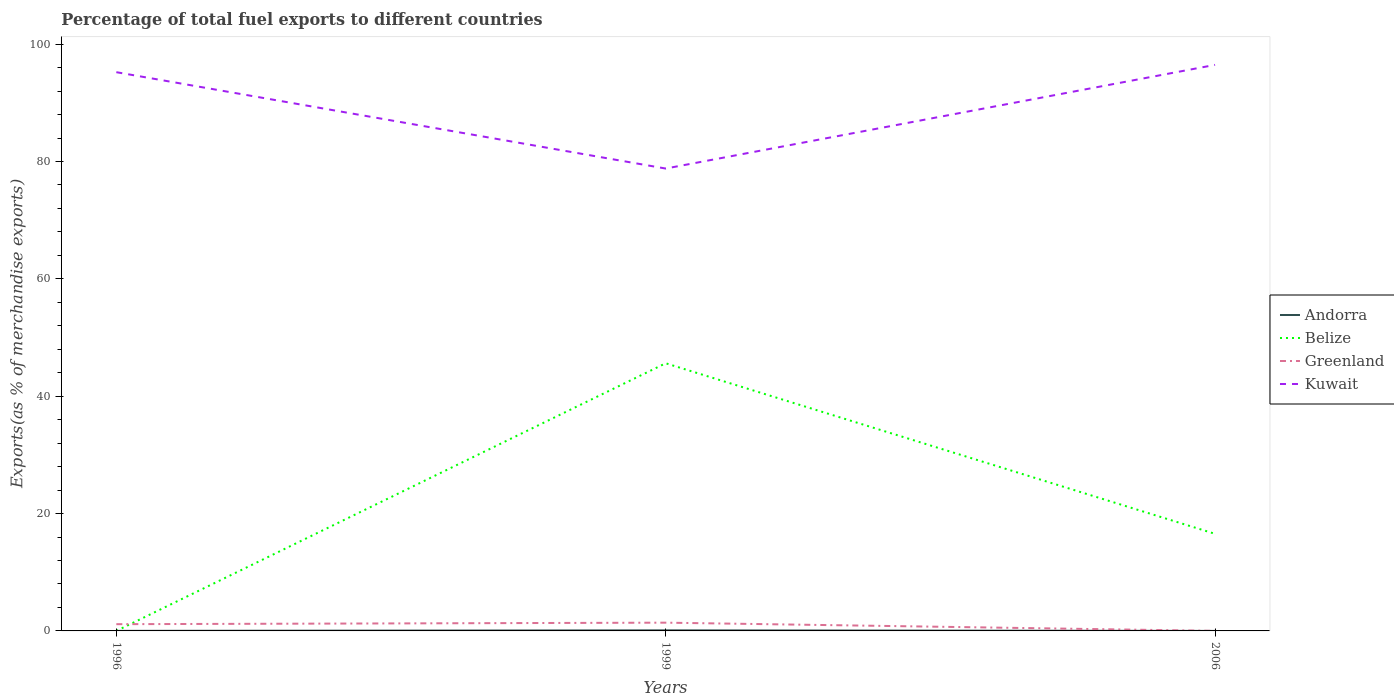Does the line corresponding to Belize intersect with the line corresponding to Kuwait?
Provide a short and direct response. No. Is the number of lines equal to the number of legend labels?
Your answer should be compact. Yes. Across all years, what is the maximum percentage of exports to different countries in Greenland?
Offer a terse response. 0.01. What is the total percentage of exports to different countries in Greenland in the graph?
Keep it short and to the point. 1.14. What is the difference between the highest and the second highest percentage of exports to different countries in Kuwait?
Your answer should be compact. 17.67. Are the values on the major ticks of Y-axis written in scientific E-notation?
Make the answer very short. No. Does the graph contain any zero values?
Make the answer very short. No. Does the graph contain grids?
Offer a very short reply. No. Where does the legend appear in the graph?
Give a very brief answer. Center right. What is the title of the graph?
Provide a succinct answer. Percentage of total fuel exports to different countries. What is the label or title of the Y-axis?
Offer a very short reply. Exports(as % of merchandise exports). What is the Exports(as % of merchandise exports) of Andorra in 1996?
Offer a very short reply. 0.01. What is the Exports(as % of merchandise exports) of Belize in 1996?
Ensure brevity in your answer.  0. What is the Exports(as % of merchandise exports) in Greenland in 1996?
Your answer should be compact. 1.15. What is the Exports(as % of merchandise exports) of Kuwait in 1996?
Give a very brief answer. 95.22. What is the Exports(as % of merchandise exports) in Andorra in 1999?
Your response must be concise. 0.1. What is the Exports(as % of merchandise exports) in Belize in 1999?
Provide a short and direct response. 45.62. What is the Exports(as % of merchandise exports) of Greenland in 1999?
Your response must be concise. 1.41. What is the Exports(as % of merchandise exports) in Kuwait in 1999?
Keep it short and to the point. 78.8. What is the Exports(as % of merchandise exports) in Andorra in 2006?
Give a very brief answer. 0. What is the Exports(as % of merchandise exports) in Belize in 2006?
Provide a succinct answer. 16.55. What is the Exports(as % of merchandise exports) of Greenland in 2006?
Provide a short and direct response. 0.01. What is the Exports(as % of merchandise exports) of Kuwait in 2006?
Ensure brevity in your answer.  96.47. Across all years, what is the maximum Exports(as % of merchandise exports) in Andorra?
Ensure brevity in your answer.  0.1. Across all years, what is the maximum Exports(as % of merchandise exports) of Belize?
Make the answer very short. 45.62. Across all years, what is the maximum Exports(as % of merchandise exports) of Greenland?
Provide a succinct answer. 1.41. Across all years, what is the maximum Exports(as % of merchandise exports) in Kuwait?
Offer a terse response. 96.47. Across all years, what is the minimum Exports(as % of merchandise exports) in Andorra?
Provide a succinct answer. 0. Across all years, what is the minimum Exports(as % of merchandise exports) in Belize?
Ensure brevity in your answer.  0. Across all years, what is the minimum Exports(as % of merchandise exports) of Greenland?
Provide a succinct answer. 0.01. Across all years, what is the minimum Exports(as % of merchandise exports) in Kuwait?
Make the answer very short. 78.8. What is the total Exports(as % of merchandise exports) of Andorra in the graph?
Your answer should be very brief. 0.11. What is the total Exports(as % of merchandise exports) of Belize in the graph?
Your answer should be very brief. 62.16. What is the total Exports(as % of merchandise exports) in Greenland in the graph?
Offer a terse response. 2.56. What is the total Exports(as % of merchandise exports) of Kuwait in the graph?
Ensure brevity in your answer.  270.5. What is the difference between the Exports(as % of merchandise exports) in Andorra in 1996 and that in 1999?
Give a very brief answer. -0.09. What is the difference between the Exports(as % of merchandise exports) in Belize in 1996 and that in 1999?
Offer a terse response. -45.62. What is the difference between the Exports(as % of merchandise exports) in Greenland in 1996 and that in 1999?
Ensure brevity in your answer.  -0.26. What is the difference between the Exports(as % of merchandise exports) in Kuwait in 1996 and that in 1999?
Offer a very short reply. 16.42. What is the difference between the Exports(as % of merchandise exports) of Andorra in 1996 and that in 2006?
Your answer should be very brief. 0.01. What is the difference between the Exports(as % of merchandise exports) in Belize in 1996 and that in 2006?
Make the answer very short. -16.55. What is the difference between the Exports(as % of merchandise exports) in Greenland in 1996 and that in 2006?
Your answer should be compact. 1.14. What is the difference between the Exports(as % of merchandise exports) of Kuwait in 1996 and that in 2006?
Make the answer very short. -1.25. What is the difference between the Exports(as % of merchandise exports) of Andorra in 1999 and that in 2006?
Provide a succinct answer. 0.1. What is the difference between the Exports(as % of merchandise exports) in Belize in 1999 and that in 2006?
Provide a short and direct response. 29.07. What is the difference between the Exports(as % of merchandise exports) in Greenland in 1999 and that in 2006?
Your response must be concise. 1.4. What is the difference between the Exports(as % of merchandise exports) of Kuwait in 1999 and that in 2006?
Offer a terse response. -17.67. What is the difference between the Exports(as % of merchandise exports) of Andorra in 1996 and the Exports(as % of merchandise exports) of Belize in 1999?
Your answer should be compact. -45.61. What is the difference between the Exports(as % of merchandise exports) in Andorra in 1996 and the Exports(as % of merchandise exports) in Greenland in 1999?
Provide a succinct answer. -1.4. What is the difference between the Exports(as % of merchandise exports) of Andorra in 1996 and the Exports(as % of merchandise exports) of Kuwait in 1999?
Provide a short and direct response. -78.79. What is the difference between the Exports(as % of merchandise exports) of Belize in 1996 and the Exports(as % of merchandise exports) of Greenland in 1999?
Provide a short and direct response. -1.41. What is the difference between the Exports(as % of merchandise exports) of Belize in 1996 and the Exports(as % of merchandise exports) of Kuwait in 1999?
Make the answer very short. -78.8. What is the difference between the Exports(as % of merchandise exports) in Greenland in 1996 and the Exports(as % of merchandise exports) in Kuwait in 1999?
Provide a succinct answer. -77.65. What is the difference between the Exports(as % of merchandise exports) of Andorra in 1996 and the Exports(as % of merchandise exports) of Belize in 2006?
Your answer should be compact. -16.54. What is the difference between the Exports(as % of merchandise exports) of Andorra in 1996 and the Exports(as % of merchandise exports) of Greenland in 2006?
Offer a terse response. 0. What is the difference between the Exports(as % of merchandise exports) of Andorra in 1996 and the Exports(as % of merchandise exports) of Kuwait in 2006?
Offer a very short reply. -96.46. What is the difference between the Exports(as % of merchandise exports) of Belize in 1996 and the Exports(as % of merchandise exports) of Greenland in 2006?
Ensure brevity in your answer.  -0.01. What is the difference between the Exports(as % of merchandise exports) of Belize in 1996 and the Exports(as % of merchandise exports) of Kuwait in 2006?
Give a very brief answer. -96.47. What is the difference between the Exports(as % of merchandise exports) in Greenland in 1996 and the Exports(as % of merchandise exports) in Kuwait in 2006?
Offer a very short reply. -95.32. What is the difference between the Exports(as % of merchandise exports) of Andorra in 1999 and the Exports(as % of merchandise exports) of Belize in 2006?
Your answer should be very brief. -16.45. What is the difference between the Exports(as % of merchandise exports) of Andorra in 1999 and the Exports(as % of merchandise exports) of Greenland in 2006?
Your response must be concise. 0.09. What is the difference between the Exports(as % of merchandise exports) of Andorra in 1999 and the Exports(as % of merchandise exports) of Kuwait in 2006?
Make the answer very short. -96.37. What is the difference between the Exports(as % of merchandise exports) of Belize in 1999 and the Exports(as % of merchandise exports) of Greenland in 2006?
Your response must be concise. 45.61. What is the difference between the Exports(as % of merchandise exports) of Belize in 1999 and the Exports(as % of merchandise exports) of Kuwait in 2006?
Provide a succinct answer. -50.85. What is the difference between the Exports(as % of merchandise exports) of Greenland in 1999 and the Exports(as % of merchandise exports) of Kuwait in 2006?
Offer a terse response. -95.06. What is the average Exports(as % of merchandise exports) of Andorra per year?
Keep it short and to the point. 0.04. What is the average Exports(as % of merchandise exports) of Belize per year?
Keep it short and to the point. 20.72. What is the average Exports(as % of merchandise exports) in Greenland per year?
Your response must be concise. 0.85. What is the average Exports(as % of merchandise exports) of Kuwait per year?
Provide a succinct answer. 90.17. In the year 1996, what is the difference between the Exports(as % of merchandise exports) of Andorra and Exports(as % of merchandise exports) of Belize?
Your answer should be very brief. 0.01. In the year 1996, what is the difference between the Exports(as % of merchandise exports) of Andorra and Exports(as % of merchandise exports) of Greenland?
Give a very brief answer. -1.14. In the year 1996, what is the difference between the Exports(as % of merchandise exports) in Andorra and Exports(as % of merchandise exports) in Kuwait?
Ensure brevity in your answer.  -95.22. In the year 1996, what is the difference between the Exports(as % of merchandise exports) of Belize and Exports(as % of merchandise exports) of Greenland?
Your answer should be very brief. -1.15. In the year 1996, what is the difference between the Exports(as % of merchandise exports) of Belize and Exports(as % of merchandise exports) of Kuwait?
Offer a terse response. -95.22. In the year 1996, what is the difference between the Exports(as % of merchandise exports) in Greenland and Exports(as % of merchandise exports) in Kuwait?
Ensure brevity in your answer.  -94.08. In the year 1999, what is the difference between the Exports(as % of merchandise exports) of Andorra and Exports(as % of merchandise exports) of Belize?
Your answer should be very brief. -45.52. In the year 1999, what is the difference between the Exports(as % of merchandise exports) in Andorra and Exports(as % of merchandise exports) in Greenland?
Give a very brief answer. -1.31. In the year 1999, what is the difference between the Exports(as % of merchandise exports) of Andorra and Exports(as % of merchandise exports) of Kuwait?
Provide a succinct answer. -78.7. In the year 1999, what is the difference between the Exports(as % of merchandise exports) of Belize and Exports(as % of merchandise exports) of Greenland?
Make the answer very short. 44.21. In the year 1999, what is the difference between the Exports(as % of merchandise exports) of Belize and Exports(as % of merchandise exports) of Kuwait?
Provide a succinct answer. -33.19. In the year 1999, what is the difference between the Exports(as % of merchandise exports) of Greenland and Exports(as % of merchandise exports) of Kuwait?
Provide a succinct answer. -77.4. In the year 2006, what is the difference between the Exports(as % of merchandise exports) of Andorra and Exports(as % of merchandise exports) of Belize?
Make the answer very short. -16.55. In the year 2006, what is the difference between the Exports(as % of merchandise exports) of Andorra and Exports(as % of merchandise exports) of Greenland?
Your response must be concise. -0.01. In the year 2006, what is the difference between the Exports(as % of merchandise exports) in Andorra and Exports(as % of merchandise exports) in Kuwait?
Offer a terse response. -96.47. In the year 2006, what is the difference between the Exports(as % of merchandise exports) of Belize and Exports(as % of merchandise exports) of Greenland?
Offer a terse response. 16.54. In the year 2006, what is the difference between the Exports(as % of merchandise exports) of Belize and Exports(as % of merchandise exports) of Kuwait?
Keep it short and to the point. -79.92. In the year 2006, what is the difference between the Exports(as % of merchandise exports) in Greenland and Exports(as % of merchandise exports) in Kuwait?
Provide a short and direct response. -96.46. What is the ratio of the Exports(as % of merchandise exports) in Andorra in 1996 to that in 1999?
Provide a succinct answer. 0.08. What is the ratio of the Exports(as % of merchandise exports) of Belize in 1996 to that in 1999?
Keep it short and to the point. 0. What is the ratio of the Exports(as % of merchandise exports) in Greenland in 1996 to that in 1999?
Provide a succinct answer. 0.82. What is the ratio of the Exports(as % of merchandise exports) of Kuwait in 1996 to that in 1999?
Ensure brevity in your answer.  1.21. What is the ratio of the Exports(as % of merchandise exports) in Andorra in 1996 to that in 2006?
Give a very brief answer. 10.46. What is the ratio of the Exports(as % of merchandise exports) of Belize in 1996 to that in 2006?
Provide a short and direct response. 0. What is the ratio of the Exports(as % of merchandise exports) in Greenland in 1996 to that in 2006?
Your answer should be very brief. 148.71. What is the ratio of the Exports(as % of merchandise exports) of Kuwait in 1996 to that in 2006?
Your answer should be compact. 0.99. What is the ratio of the Exports(as % of merchandise exports) of Andorra in 1999 to that in 2006?
Your answer should be compact. 128.55. What is the ratio of the Exports(as % of merchandise exports) of Belize in 1999 to that in 2006?
Your answer should be very brief. 2.76. What is the ratio of the Exports(as % of merchandise exports) in Greenland in 1999 to that in 2006?
Your answer should be compact. 182.09. What is the ratio of the Exports(as % of merchandise exports) in Kuwait in 1999 to that in 2006?
Your answer should be compact. 0.82. What is the difference between the highest and the second highest Exports(as % of merchandise exports) of Andorra?
Your response must be concise. 0.09. What is the difference between the highest and the second highest Exports(as % of merchandise exports) of Belize?
Offer a very short reply. 29.07. What is the difference between the highest and the second highest Exports(as % of merchandise exports) of Greenland?
Your answer should be compact. 0.26. What is the difference between the highest and the second highest Exports(as % of merchandise exports) of Kuwait?
Give a very brief answer. 1.25. What is the difference between the highest and the lowest Exports(as % of merchandise exports) of Andorra?
Offer a very short reply. 0.1. What is the difference between the highest and the lowest Exports(as % of merchandise exports) in Belize?
Your answer should be compact. 45.62. What is the difference between the highest and the lowest Exports(as % of merchandise exports) of Greenland?
Give a very brief answer. 1.4. What is the difference between the highest and the lowest Exports(as % of merchandise exports) in Kuwait?
Your answer should be compact. 17.67. 